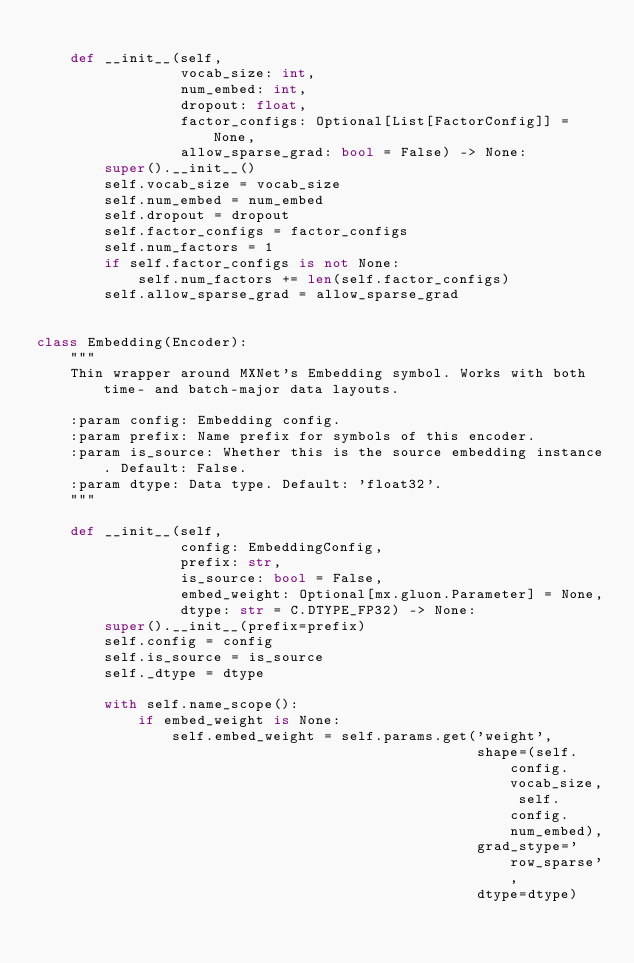Convert code to text. <code><loc_0><loc_0><loc_500><loc_500><_Python_>
    def __init__(self,
                 vocab_size: int,
                 num_embed: int,
                 dropout: float,
                 factor_configs: Optional[List[FactorConfig]] = None,
                 allow_sparse_grad: bool = False) -> None:
        super().__init__()
        self.vocab_size = vocab_size
        self.num_embed = num_embed
        self.dropout = dropout
        self.factor_configs = factor_configs
        self.num_factors = 1
        if self.factor_configs is not None:
            self.num_factors += len(self.factor_configs)
        self.allow_sparse_grad = allow_sparse_grad


class Embedding(Encoder):
    """
    Thin wrapper around MXNet's Embedding symbol. Works with both time- and batch-major data layouts.

    :param config: Embedding config.
    :param prefix: Name prefix for symbols of this encoder.
    :param is_source: Whether this is the source embedding instance. Default: False.
    :param dtype: Data type. Default: 'float32'.
    """

    def __init__(self,
                 config: EmbeddingConfig,
                 prefix: str,
                 is_source: bool = False,
                 embed_weight: Optional[mx.gluon.Parameter] = None,
                 dtype: str = C.DTYPE_FP32) -> None:
        super().__init__(prefix=prefix)
        self.config = config
        self.is_source = is_source
        self._dtype = dtype

        with self.name_scope():
            if embed_weight is None:
                self.embed_weight = self.params.get('weight',
                                                    shape=(self.config.vocab_size, self.config.num_embed),
                                                    grad_stype='row_sparse',
                                                    dtype=dtype)</code> 